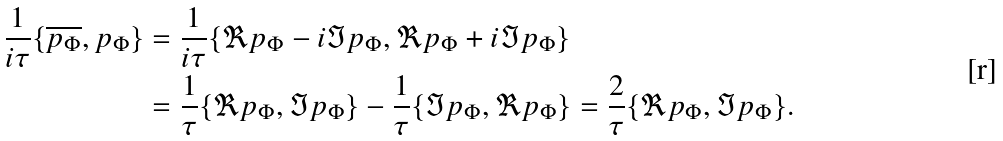<formula> <loc_0><loc_0><loc_500><loc_500>\frac { 1 } { i \tau } \{ \overline { p _ { \Phi } } , p _ { \Phi } \} & = \frac { 1 } { i \tau } \{ \Re p _ { \Phi } - i \Im p _ { \Phi } , \Re p _ { \Phi } + i \Im p _ { \Phi } \} \\ & = \frac { 1 } { \tau } \{ \Re p _ { \Phi } , \Im p _ { \Phi } \} - \frac { 1 } { \tau } \{ \Im p _ { \Phi } , \Re p _ { \Phi } \} = \frac { 2 } { \tau } \{ \Re p _ { \Phi } , \Im p _ { \Phi } \} .</formula> 